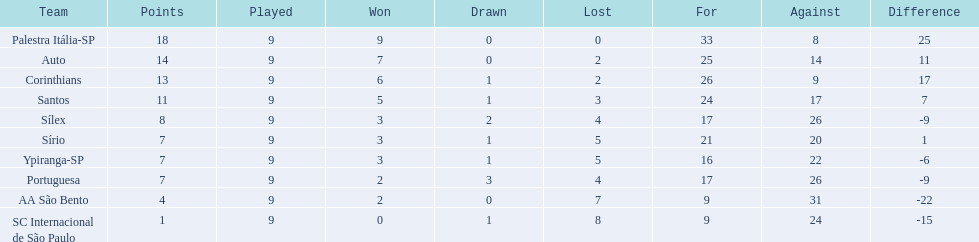Brazilian football in 1926 what teams had no draws? Palestra Itália-SP, Auto, AA São Bento. Of the teams with no draws name the 2 who lost the lease. Palestra Itália-SP, Auto. What team of the 2 who lost the least and had no draws had the highest difference? Palestra Itália-SP. 